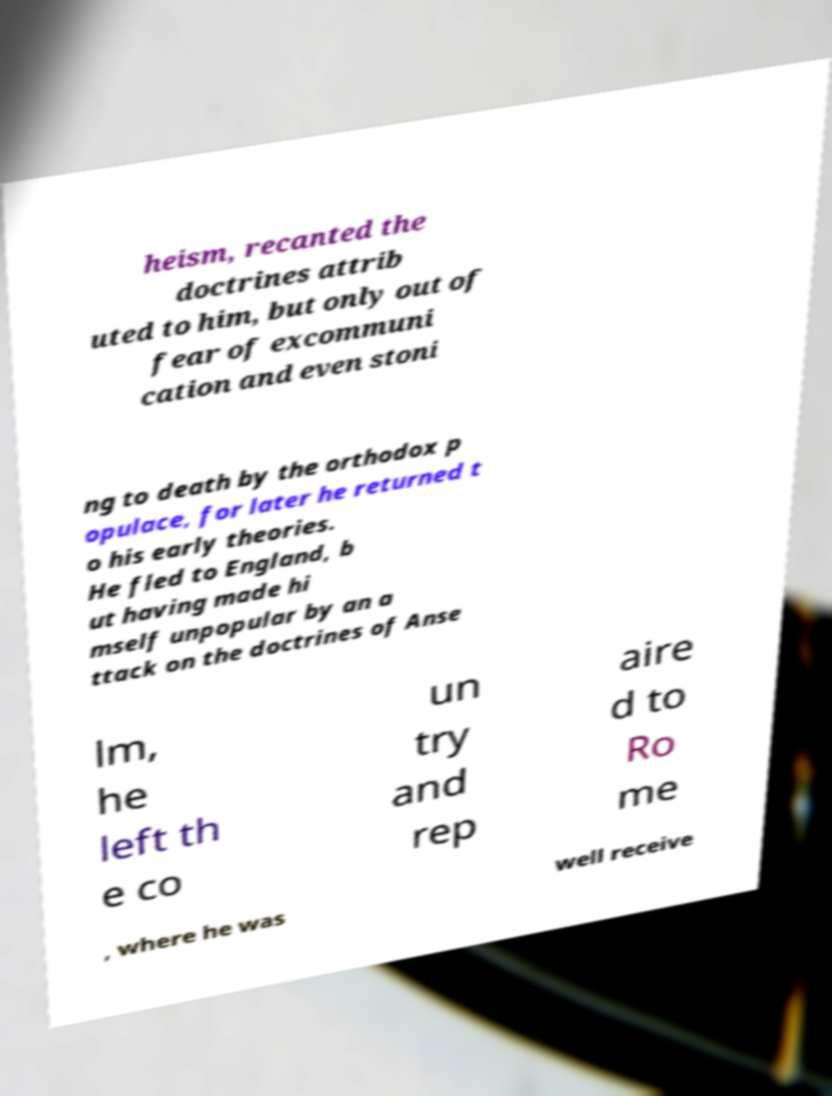There's text embedded in this image that I need extracted. Can you transcribe it verbatim? heism, recanted the doctrines attrib uted to him, but only out of fear of excommuni cation and even stoni ng to death by the orthodox p opulace, for later he returned t o his early theories. He fled to England, b ut having made hi mself unpopular by an a ttack on the doctrines of Anse lm, he left th e co un try and rep aire d to Ro me , where he was well receive 